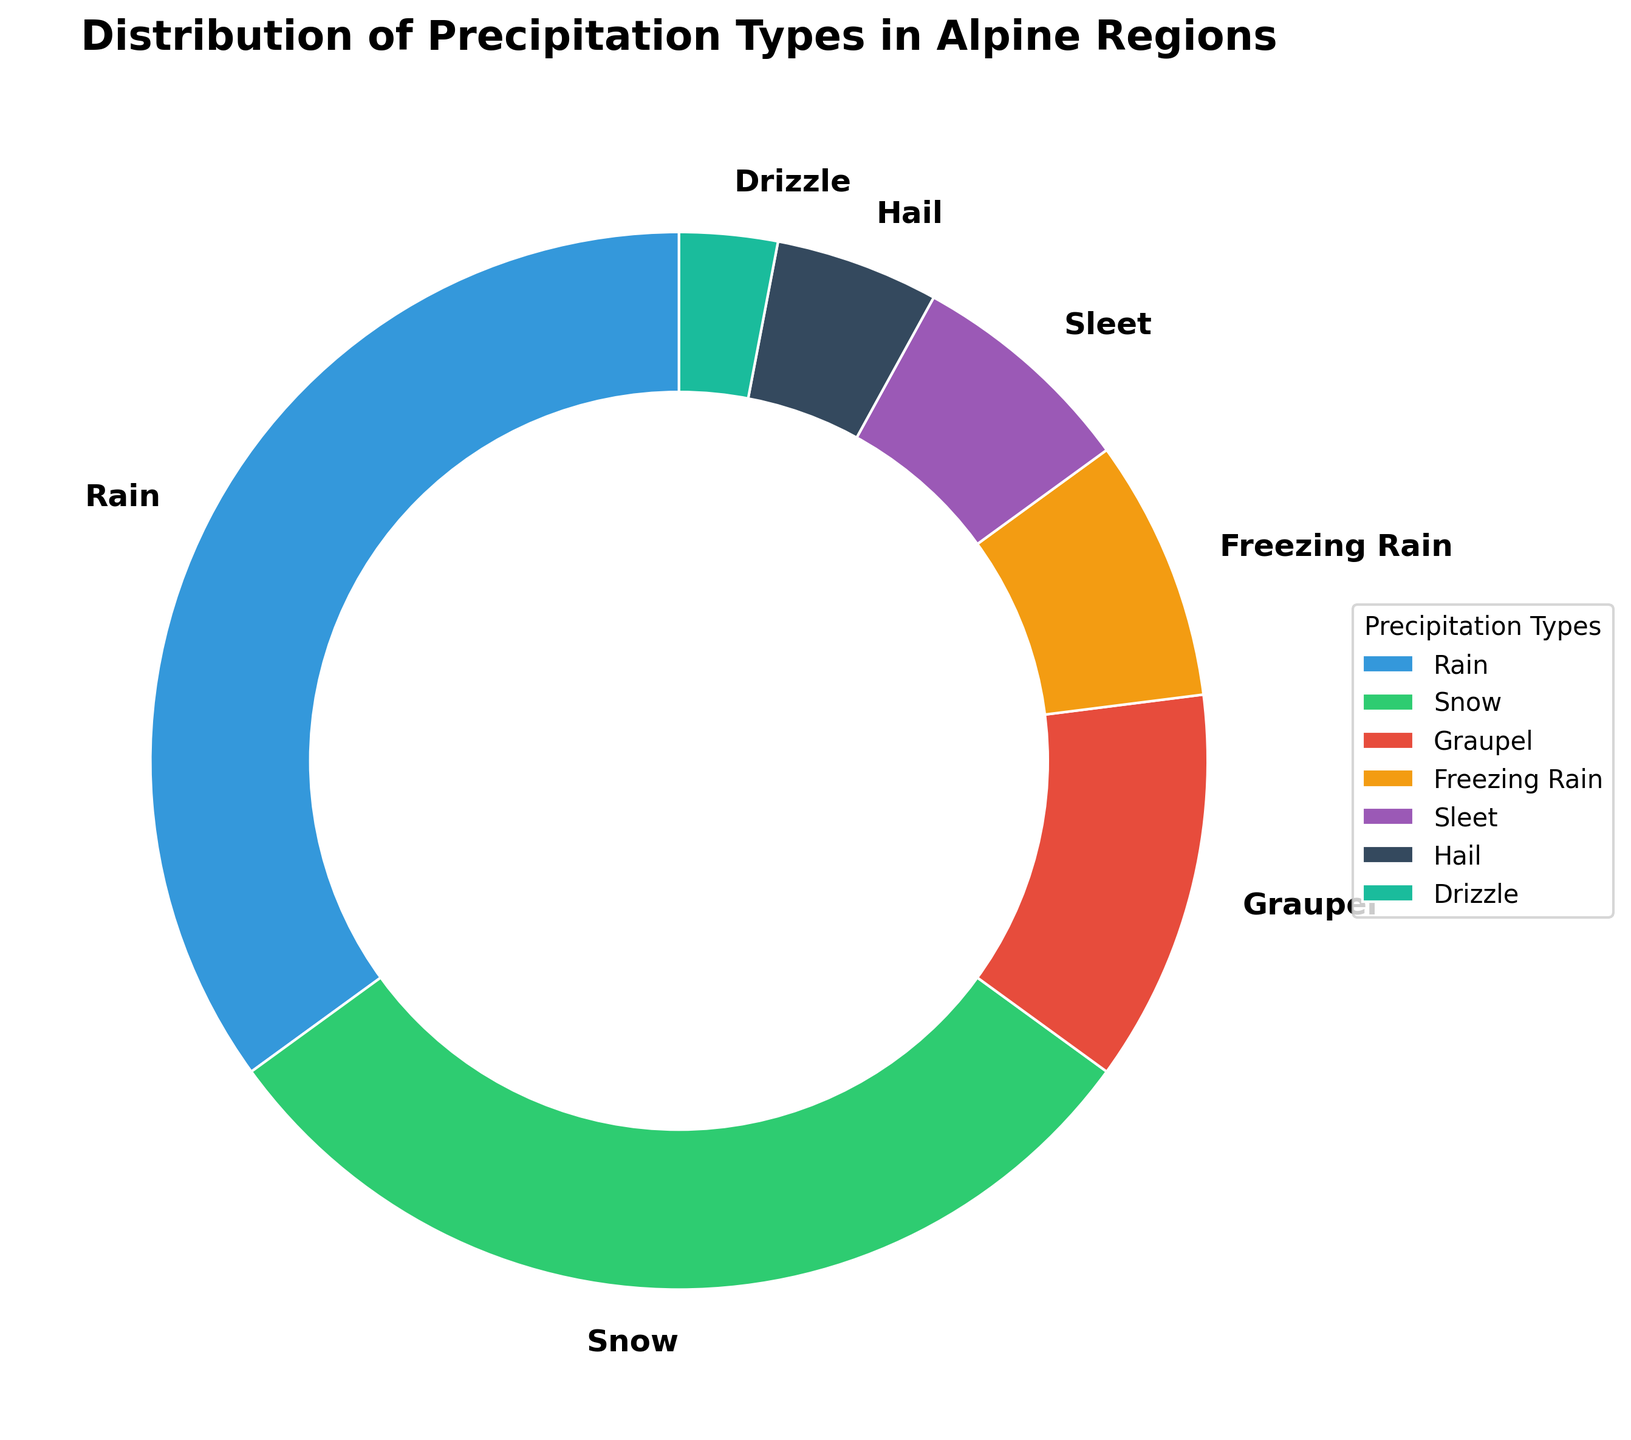What is the most common type of precipitation in alpine regions? Look at the pie chart and identify the slice with the largest percentage. The label for this slice indicates the most common type of precipitation.
Answer: Rain What percentage of precipitation is composed of snow and hail combined? Find the individual percentages for snow and hail in the pie chart and add them together (30% for snow + 5% for hail).
Answer: 35% Which is more common in alpine regions, sleet or freezing rain? Compare the percentages of sleet and freezing rain shown in the pie chart. Sleet has 7% and freezing rain has 8%.
Answer: Freezing Rain Among the precipitation types with a percentage of 10% or higher, what is the average percentage? Identify the percentages that are 10% or higher: Rain (35%), Snow (30%), and Graupel (12%). Calculate the average: (35 + 30 + 12) / 3.
Answer: 25.7% How many types of precipitation have a percentage less than 10% in alpine regions? Count the slices in the pie chart that show a percentage less than 10%: Graupel (12%), Freezing Rain (8%), Sleet (7%), Hail (5%), and Drizzle (3%).
Answer: 4 Which color represents the drizzle in the pie chart? Look at the label associated with "Drizzle" in the pie chart to identify its color.
Answer: Green What is the difference in percentage between snow and graupel? Subtract the percentage of graupel from that of snow: 30% (Snow) - 12% (Graupel).
Answer: 18% Is freezing rain more or less common than graupel in alpine regions? Compare the percentages for freezing rain and graupel in the pie chart. Freezing rain is 8% while graupel is 12%.
Answer: Less How many types of precipitation, other than rain, make up more than 10% of the total? Exclude rain and identify the remaining types that exceed 10%: Snow (30%) and Graupel (12%).
Answer: 2 